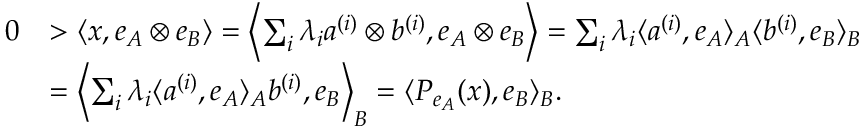Convert formula to latex. <formula><loc_0><loc_0><loc_500><loc_500>\begin{array} { r l } { 0 } & { > \langle x , e _ { A } \otimes e _ { B } \rangle = \left \langle \sum _ { i } \lambda _ { i } a ^ { ( i ) } \otimes b ^ { ( i ) } , e _ { A } \otimes e _ { B } \right \rangle = \sum _ { i } \lambda _ { i } \langle a ^ { ( i ) } , e _ { A } \rangle _ { A } \langle b ^ { ( i ) } , e _ { B } \rangle _ { B } } \\ & { = \left \langle \sum _ { i } \lambda _ { i } \langle a ^ { ( i ) } , e _ { A } \rangle _ { A } b ^ { ( i ) } , e _ { B } \right \rangle _ { B } = \langle P _ { e _ { A } } ( x ) , e _ { B } \rangle _ { B } . } \end{array}</formula> 